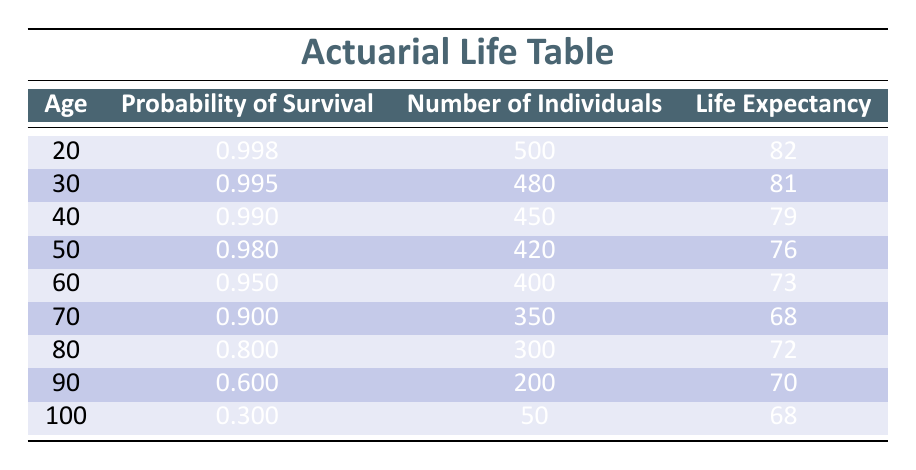What is the life expectancy for individuals at the age of 50? From the table, the life expectancy for the age of 50 is listed directly under the "Life Expectancy" column. The value provided is 76.
Answer: 76 What is the probability of survival for individuals aged 80? In the table, the probability of survival for those aged 80 is found in the second column under the "Probability of Survival" header. The value is 0.800.
Answer: 0.800 How many individuals are there at the age of 40? Looking at the table in the "Number of Individuals" column for age 40, we can see that there are 450 individuals at this age.
Answer: 450 Is the probability of survival higher for 30-year-olds or 40-year-olds? We compare the probabilities of survival for both ages. The table shows 0.995 for age 30 and 0.990 for age 40. Since 0.995 is greater than 0.990, the probability is higher for 30-year-olds.
Answer: Yes What is the average life expectancy of individuals between the ages of 70 and 100 inclusive? To calculate the average, we first find the life expectancy values for ages 70 (68), 80 (72), 90 (70), and 100 (68). Adding these together gives us 68 + 72 + 70 + 68 = 278. Then, we divide by the number of ages, which is 4. The average is 278 / 4 = 69.5.
Answer: 69.5 What is the total number of individuals in the age group of 60 and above? We will sum the number of individuals for ages 60 (400), 70 (350), 80 (300), 90 (200), and 100 (50). The total is 400 + 350 + 300 + 200 + 50 = 1300.
Answer: 1300 What age group shows the lowest probability of survival? We need to look at the "Probability of Survival" column and find the minimum value. The lowest probability is 0.300 for the age group of 100.
Answer: 100 How many more individuals are there at age 20 compared to age 90? We take the number of individuals at age 20 (500) and subtract the number at age 90 (200). The difference is 500 - 200 = 300 individuals.
Answer: 300 What is the trend in life expectancy as age increases from 20 to 100? By examining the table, we can observe that life expectancy decreases as age increases, starting from 82 at age 20 and going down to 68 at age 100.
Answer: Decreases 